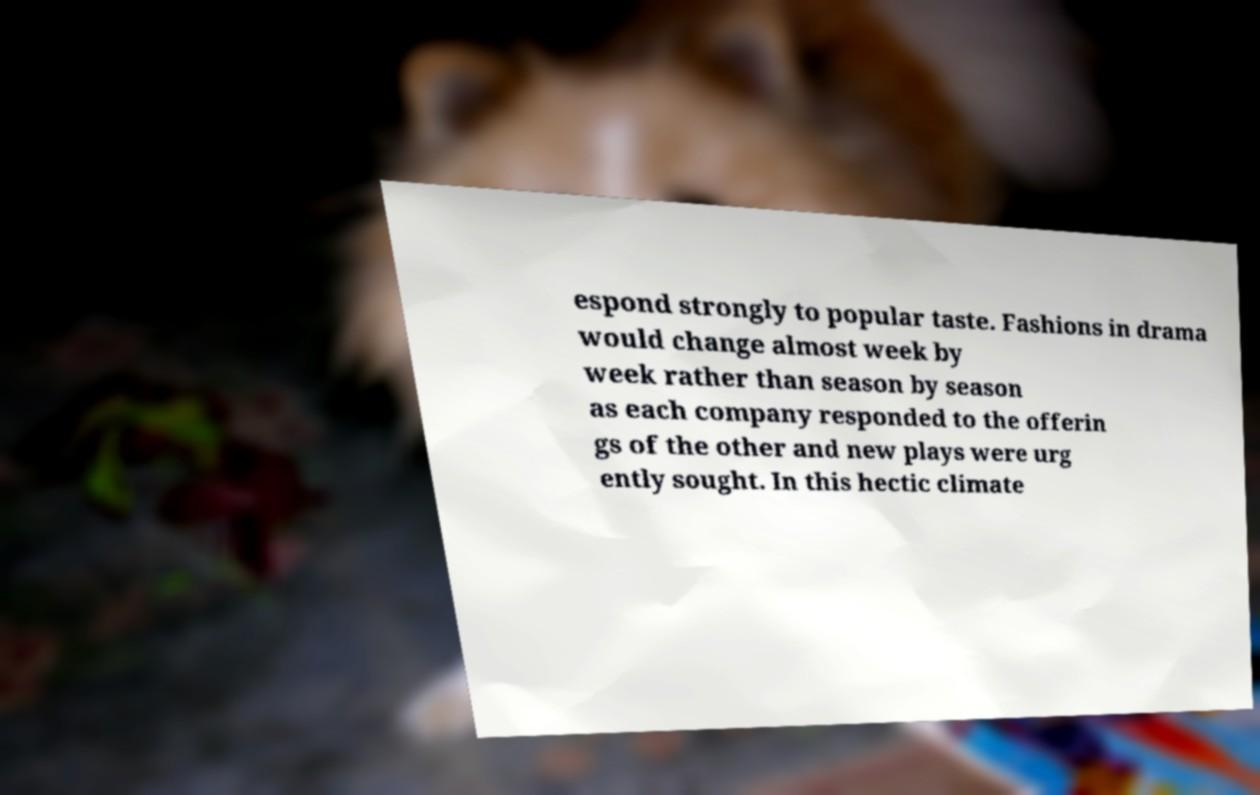Can you read and provide the text displayed in the image?This photo seems to have some interesting text. Can you extract and type it out for me? espond strongly to popular taste. Fashions in drama would change almost week by week rather than season by season as each company responded to the offerin gs of the other and new plays were urg ently sought. In this hectic climate 